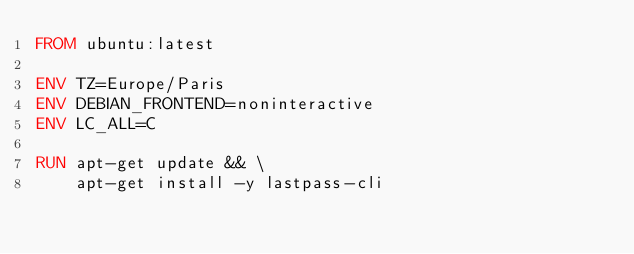Convert code to text. <code><loc_0><loc_0><loc_500><loc_500><_Dockerfile_>FROM ubuntu:latest

ENV TZ=Europe/Paris
ENV DEBIAN_FRONTEND=noninteractive
ENV LC_ALL=C

RUN apt-get update && \
    apt-get install -y lastpass-cli
</code> 